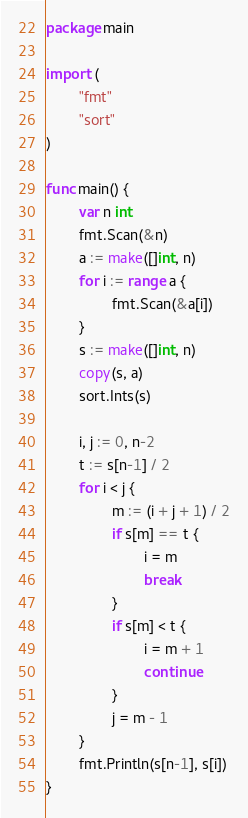<code> <loc_0><loc_0><loc_500><loc_500><_Go_>package main

import (
        "fmt"
        "sort"
)

func main() {
        var n int
        fmt.Scan(&n)
        a := make([]int, n)
        for i := range a {
                fmt.Scan(&a[i])
        }
        s := make([]int, n)
        copy(s, a)
        sort.Ints(s)

        i, j := 0, n-2
        t := s[n-1] / 2
        for i < j {
                m := (i + j + 1) / 2
                if s[m] == t {
                        i = m
                        break
                }
                if s[m] < t {
                        i = m + 1
                        continue
                }
                j = m - 1
        }
        fmt.Println(s[n-1], s[i])
}</code> 